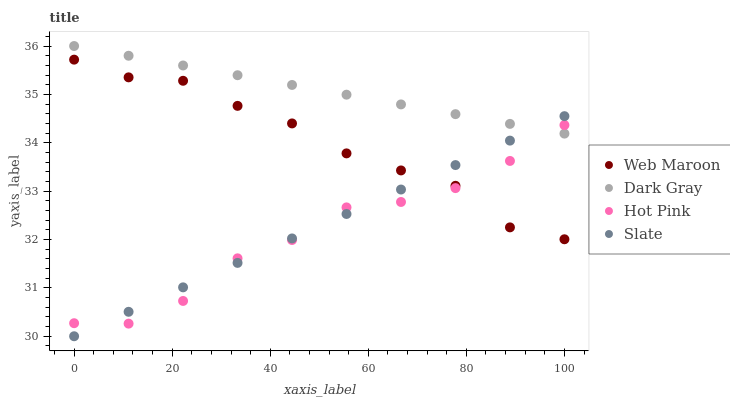Does Hot Pink have the minimum area under the curve?
Answer yes or no. Yes. Does Dark Gray have the maximum area under the curve?
Answer yes or no. Yes. Does Slate have the minimum area under the curve?
Answer yes or no. No. Does Slate have the maximum area under the curve?
Answer yes or no. No. Is Dark Gray the smoothest?
Answer yes or no. Yes. Is Hot Pink the roughest?
Answer yes or no. Yes. Is Slate the smoothest?
Answer yes or no. No. Is Slate the roughest?
Answer yes or no. No. Does Slate have the lowest value?
Answer yes or no. Yes. Does Hot Pink have the lowest value?
Answer yes or no. No. Does Dark Gray have the highest value?
Answer yes or no. Yes. Does Slate have the highest value?
Answer yes or no. No. Is Web Maroon less than Dark Gray?
Answer yes or no. Yes. Is Dark Gray greater than Web Maroon?
Answer yes or no. Yes. Does Web Maroon intersect Slate?
Answer yes or no. Yes. Is Web Maroon less than Slate?
Answer yes or no. No. Is Web Maroon greater than Slate?
Answer yes or no. No. Does Web Maroon intersect Dark Gray?
Answer yes or no. No. 